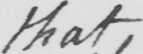Can you tell me what this handwritten text says? that 